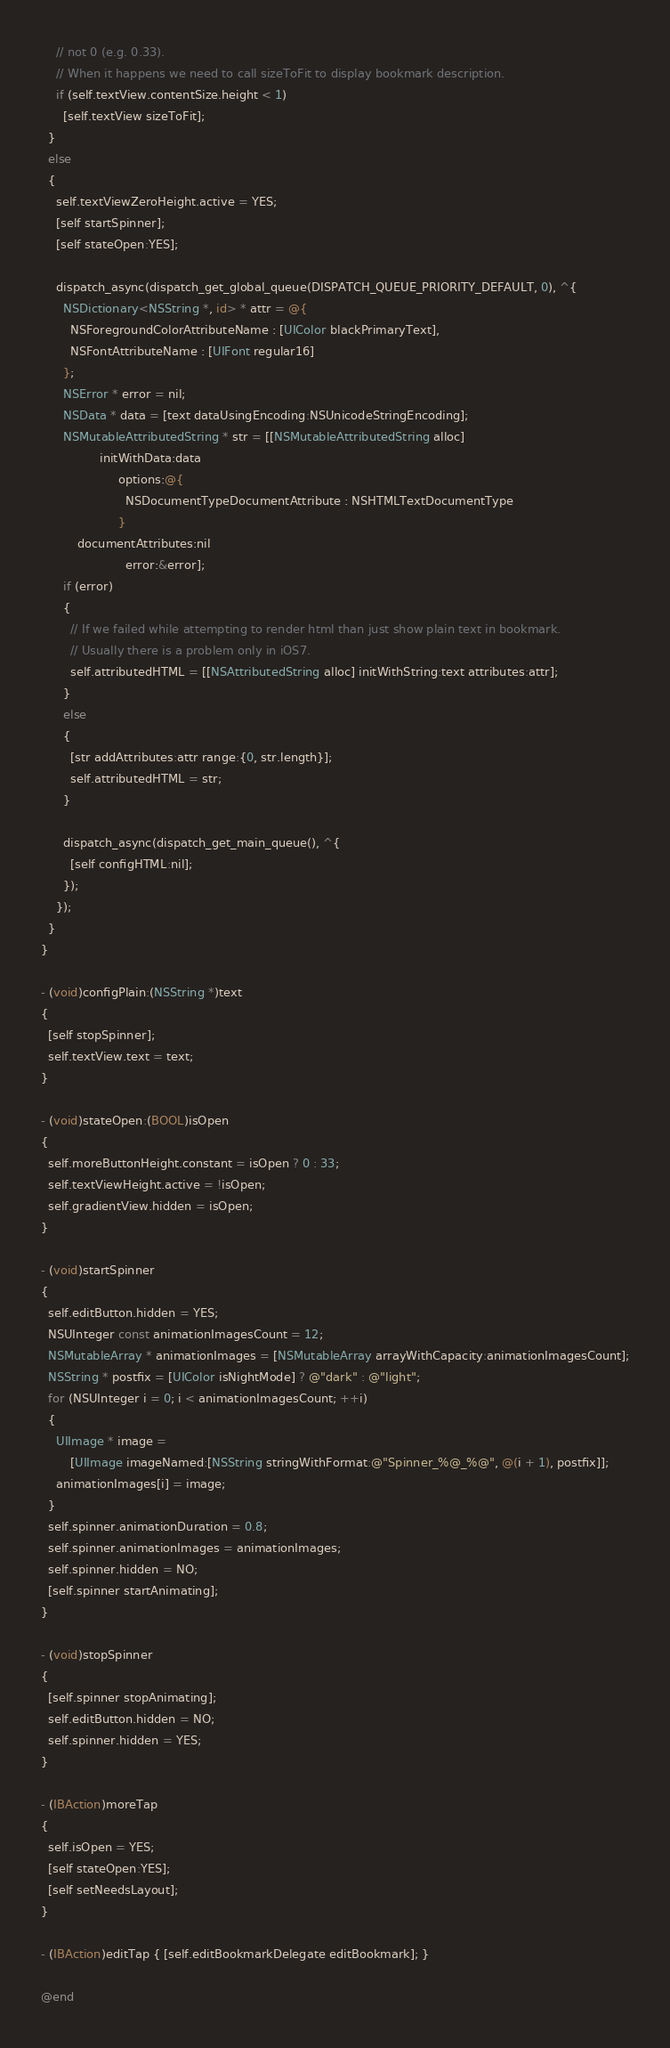<code> <loc_0><loc_0><loc_500><loc_500><_ObjectiveC_>    // not 0 (e.g. 0.33).
    // When it happens we need to call sizeToFit to display bookmark description.
    if (self.textView.contentSize.height < 1)
      [self.textView sizeToFit];
  }
  else
  {
    self.textViewZeroHeight.active = YES;
    [self startSpinner];
    [self stateOpen:YES];

    dispatch_async(dispatch_get_global_queue(DISPATCH_QUEUE_PRIORITY_DEFAULT, 0), ^{
      NSDictionary<NSString *, id> * attr = @{
        NSForegroundColorAttributeName : [UIColor blackPrimaryText],
        NSFontAttributeName : [UIFont regular16]
      };
      NSError * error = nil;
      NSData * data = [text dataUsingEncoding:NSUnicodeStringEncoding];
      NSMutableAttributedString * str = [[NSMutableAttributedString alloc]
                initWithData:data
                     options:@{
                       NSDocumentTypeDocumentAttribute : NSHTMLTextDocumentType
                     }
          documentAttributes:nil
                       error:&error];
      if (error)
      {
        // If we failed while attempting to render html than just show plain text in bookmark.
        // Usually there is a problem only in iOS7.
        self.attributedHTML = [[NSAttributedString alloc] initWithString:text attributes:attr];
      }
      else
      {
        [str addAttributes:attr range:{0, str.length}];
        self.attributedHTML = str;
      }

      dispatch_async(dispatch_get_main_queue(), ^{
        [self configHTML:nil];
      });
    });
  }
}

- (void)configPlain:(NSString *)text
{
  [self stopSpinner];
  self.textView.text = text;
}

- (void)stateOpen:(BOOL)isOpen
{
  self.moreButtonHeight.constant = isOpen ? 0 : 33;
  self.textViewHeight.active = !isOpen;
  self.gradientView.hidden = isOpen;
}

- (void)startSpinner
{
  self.editButton.hidden = YES;
  NSUInteger const animationImagesCount = 12;
  NSMutableArray * animationImages = [NSMutableArray arrayWithCapacity:animationImagesCount];
  NSString * postfix = [UIColor isNightMode] ? @"dark" : @"light";
  for (NSUInteger i = 0; i < animationImagesCount; ++i)
  {
    UIImage * image =
        [UIImage imageNamed:[NSString stringWithFormat:@"Spinner_%@_%@", @(i + 1), postfix]];
    animationImages[i] = image;
  }
  self.spinner.animationDuration = 0.8;
  self.spinner.animationImages = animationImages;
  self.spinner.hidden = NO;
  [self.spinner startAnimating];
}

- (void)stopSpinner
{
  [self.spinner stopAnimating];
  self.editButton.hidden = NO;
  self.spinner.hidden = YES;
}

- (IBAction)moreTap
{
  self.isOpen = YES;
  [self stateOpen:YES];
  [self setNeedsLayout];
}

- (IBAction)editTap { [self.editBookmarkDelegate editBookmark]; }

@end
</code> 